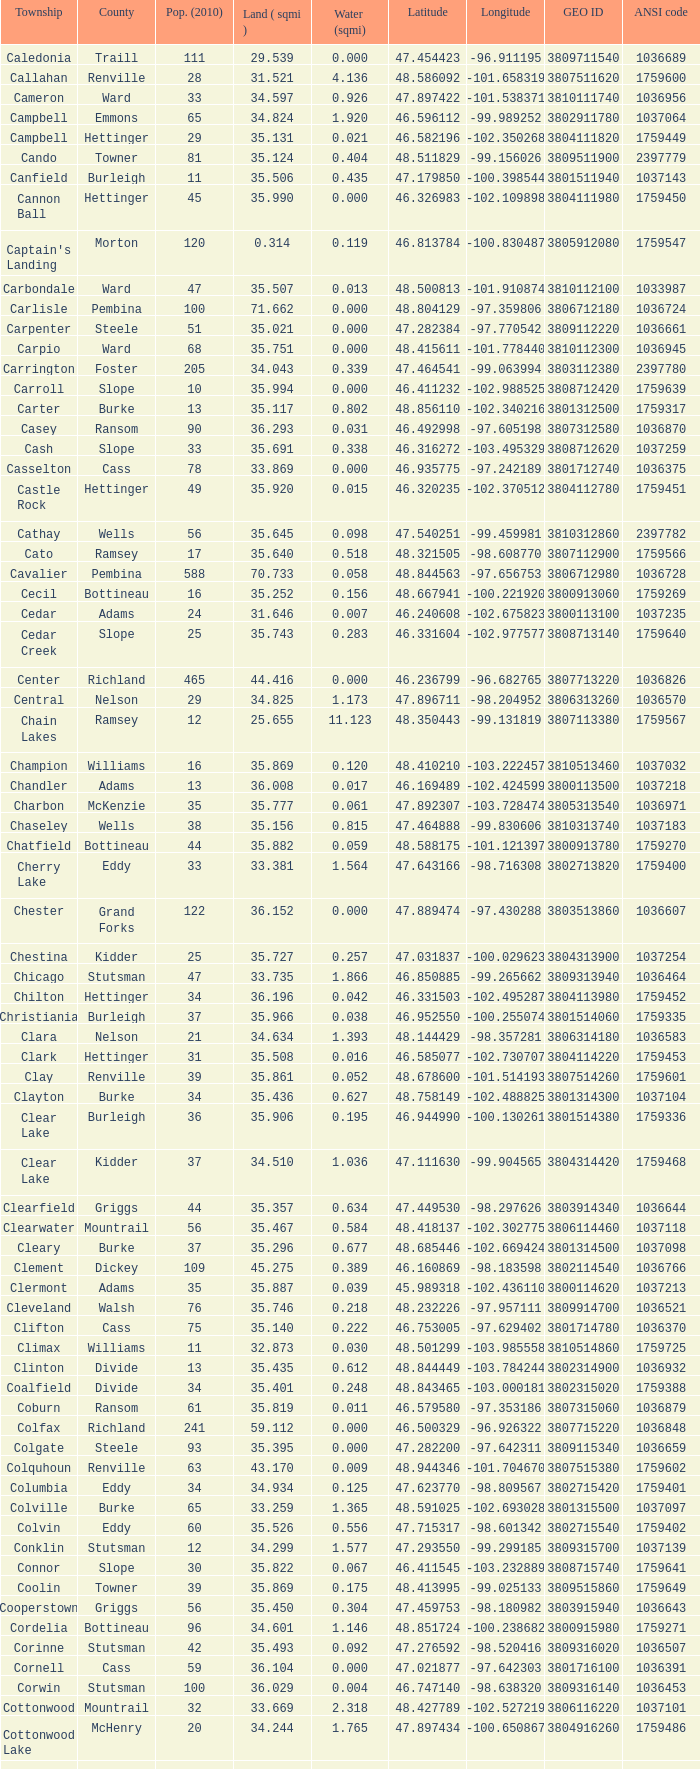075823? -98.857272. 